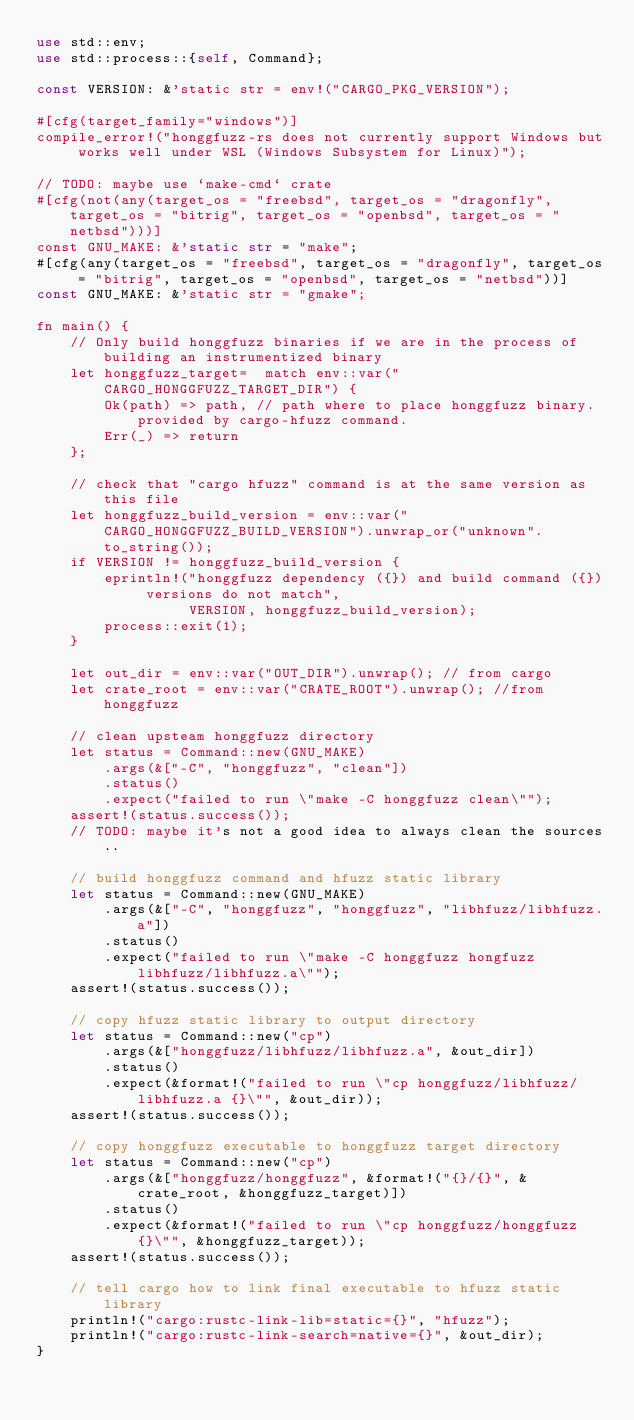Convert code to text. <code><loc_0><loc_0><loc_500><loc_500><_Rust_>use std::env;
use std::process::{self, Command};

const VERSION: &'static str = env!("CARGO_PKG_VERSION");

#[cfg(target_family="windows")]
compile_error!("honggfuzz-rs does not currently support Windows but works well under WSL (Windows Subsystem for Linux)");

// TODO: maybe use `make-cmd` crate
#[cfg(not(any(target_os = "freebsd", target_os = "dragonfly", target_os = "bitrig", target_os = "openbsd", target_os = "netbsd")))]
const GNU_MAKE: &'static str = "make";
#[cfg(any(target_os = "freebsd", target_os = "dragonfly", target_os = "bitrig", target_os = "openbsd", target_os = "netbsd"))]
const GNU_MAKE: &'static str = "gmake";

fn main() {
    // Only build honggfuzz binaries if we are in the process of building an instrumentized binary
    let honggfuzz_target=  match env::var("CARGO_HONGGFUZZ_TARGET_DIR") {
        Ok(path) => path, // path where to place honggfuzz binary. provided by cargo-hfuzz command.
        Err(_) => return
    };

    // check that "cargo hfuzz" command is at the same version as this file
    let honggfuzz_build_version = env::var("CARGO_HONGGFUZZ_BUILD_VERSION").unwrap_or("unknown".to_string());
    if VERSION != honggfuzz_build_version {
        eprintln!("honggfuzz dependency ({}) and build command ({}) versions do not match",
                  VERSION, honggfuzz_build_version);
        process::exit(1);
    }

    let out_dir = env::var("OUT_DIR").unwrap(); // from cargo
    let crate_root = env::var("CRATE_ROOT").unwrap(); //from honggfuzz

    // clean upsteam honggfuzz directory
    let status = Command::new(GNU_MAKE)
        .args(&["-C", "honggfuzz", "clean"])
        .status()
        .expect("failed to run \"make -C honggfuzz clean\"");
    assert!(status.success());
    // TODO: maybe it's not a good idea to always clean the sources..

    // build honggfuzz command and hfuzz static library
    let status = Command::new(GNU_MAKE)
        .args(&["-C", "honggfuzz", "honggfuzz", "libhfuzz/libhfuzz.a"])
        .status()
        .expect("failed to run \"make -C honggfuzz hongfuzz libhfuzz/libhfuzz.a\"");
    assert!(status.success());

    // copy hfuzz static library to output directory
    let status = Command::new("cp")
        .args(&["honggfuzz/libhfuzz/libhfuzz.a", &out_dir])
        .status()
        .expect(&format!("failed to run \"cp honggfuzz/libhfuzz/libhfuzz.a {}\"", &out_dir));
    assert!(status.success());

    // copy honggfuzz executable to honggfuzz target directory
    let status = Command::new("cp")
        .args(&["honggfuzz/honggfuzz", &format!("{}/{}", &crate_root, &honggfuzz_target)])
        .status()
        .expect(&format!("failed to run \"cp honggfuzz/honggfuzz {}\"", &honggfuzz_target));
    assert!(status.success());

    // tell cargo how to link final executable to hfuzz static library
    println!("cargo:rustc-link-lib=static={}", "hfuzz");
    println!("cargo:rustc-link-search=native={}", &out_dir);
}
</code> 